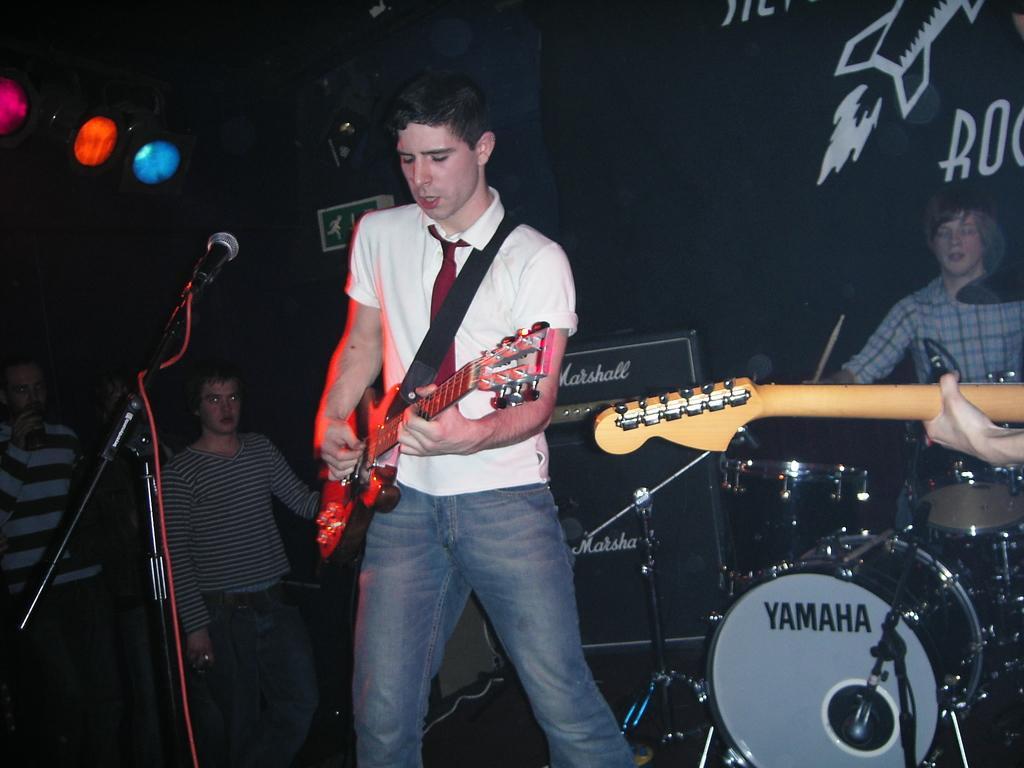Describe this image in one or two sentences. In this image the man in the foreground is playing the guitar and there is a mic in front of him. At the background there are people standing. The person to the right side is playing the drums. On the top there are lights. 